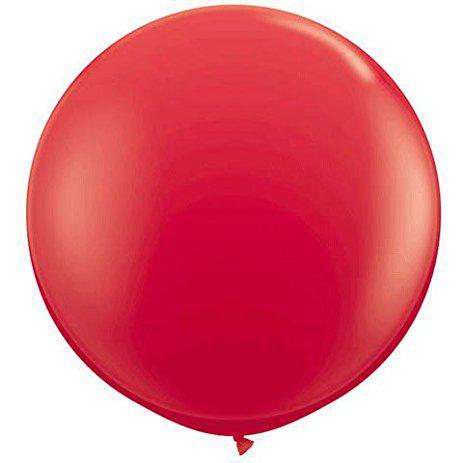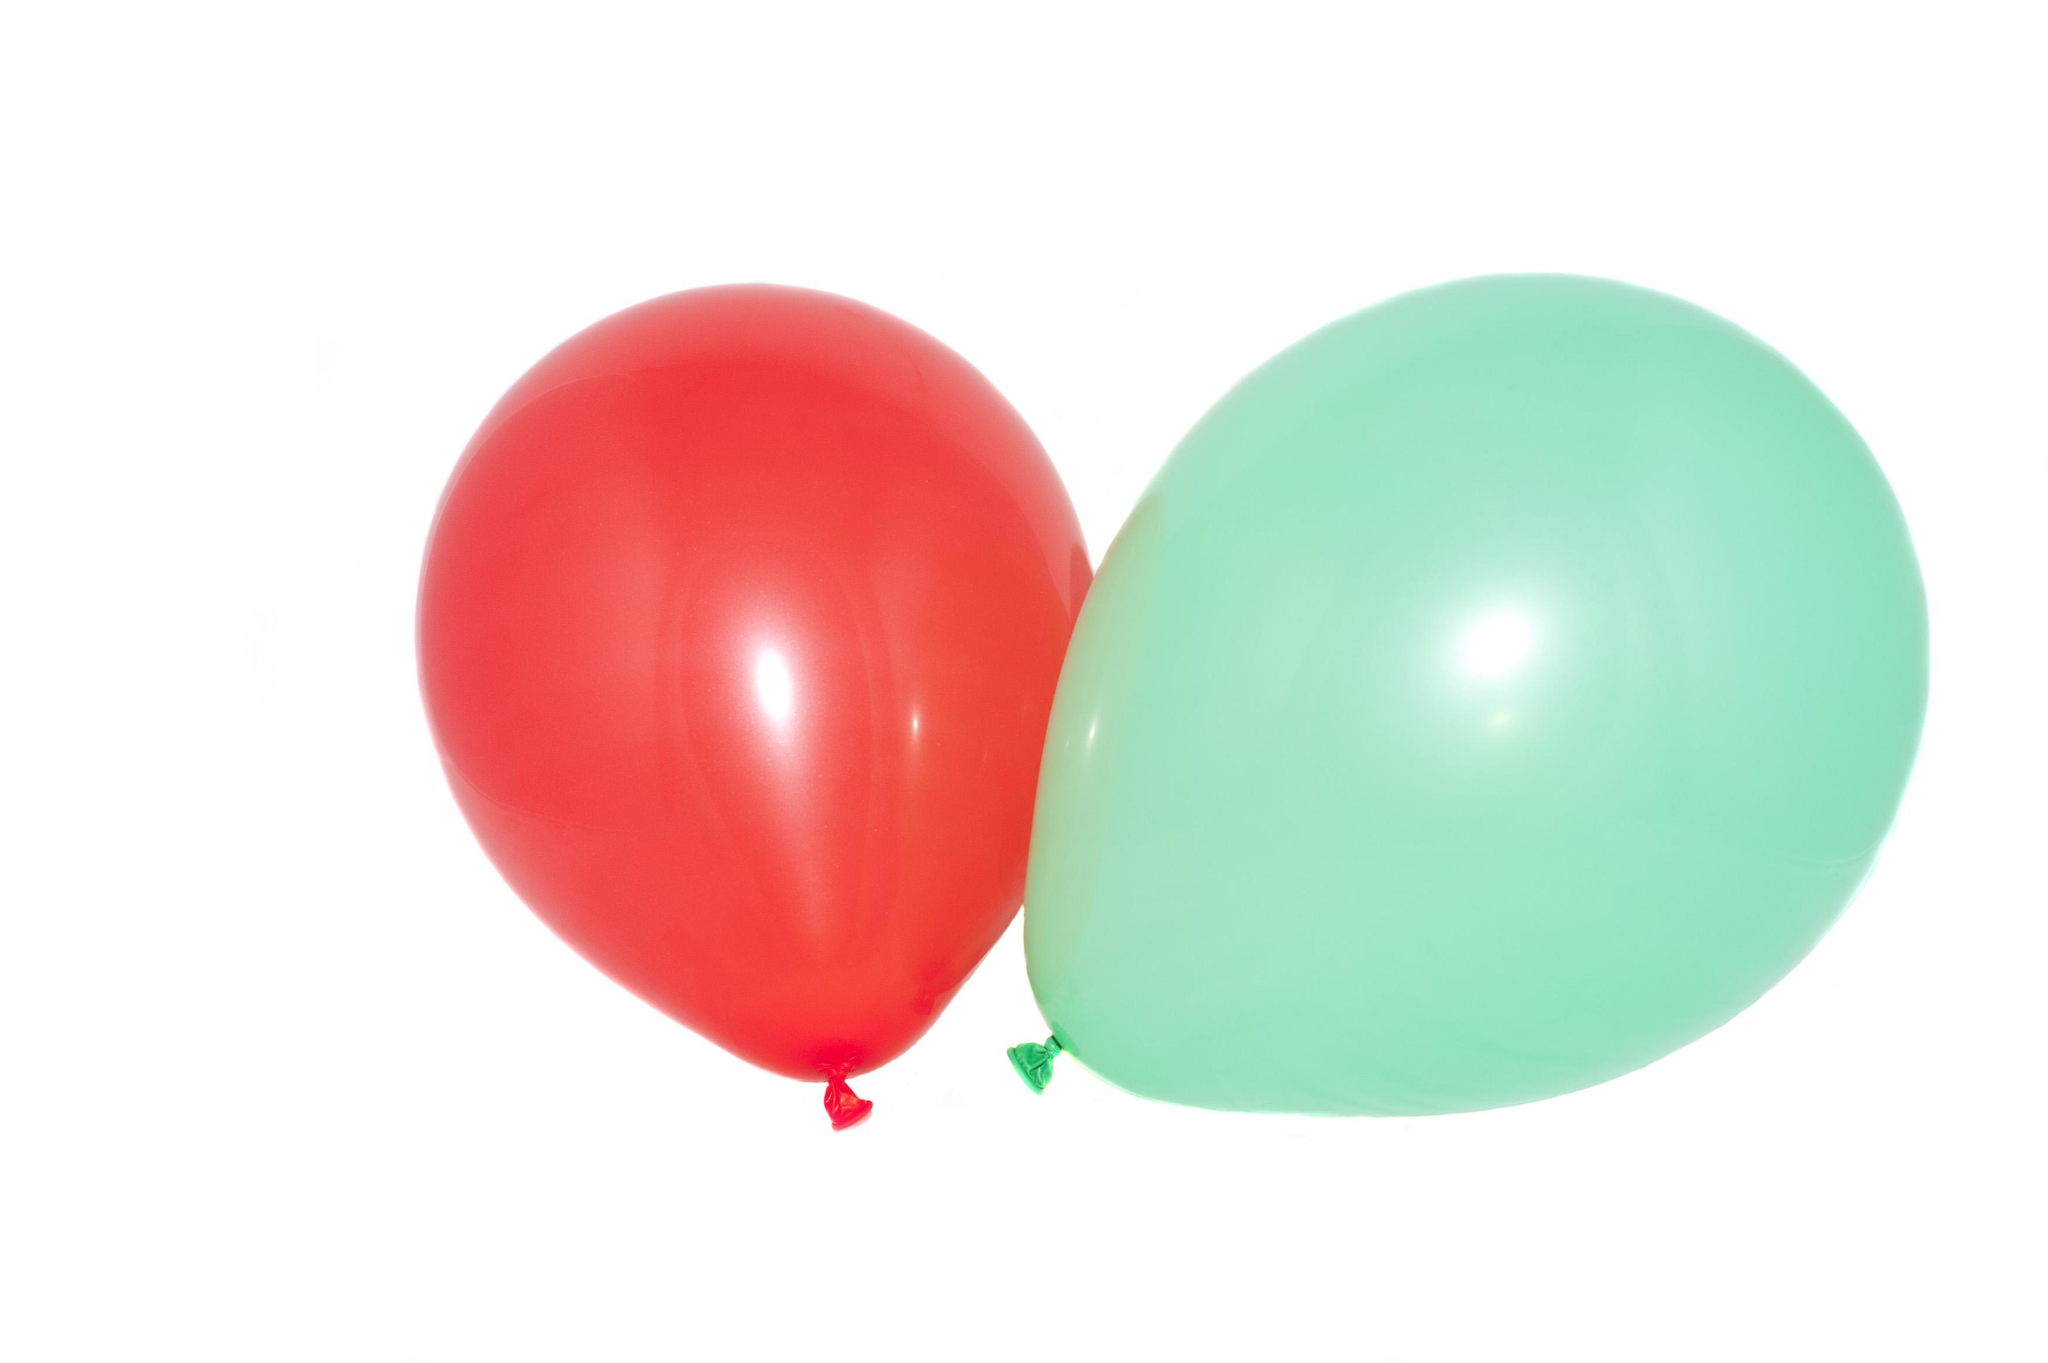The first image is the image on the left, the second image is the image on the right. Assess this claim about the two images: "There are two red balloons out of the four shown.". Correct or not? Answer yes or no. No. 